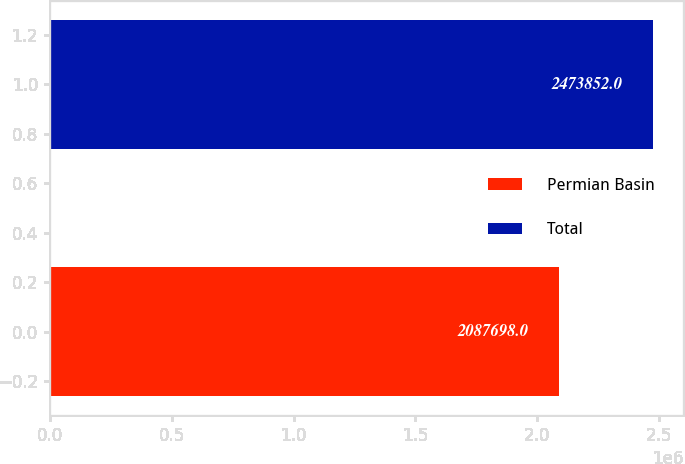Convert chart to OTSL. <chart><loc_0><loc_0><loc_500><loc_500><bar_chart><fcel>Permian Basin<fcel>Total<nl><fcel>2.0877e+06<fcel>2.47385e+06<nl></chart> 